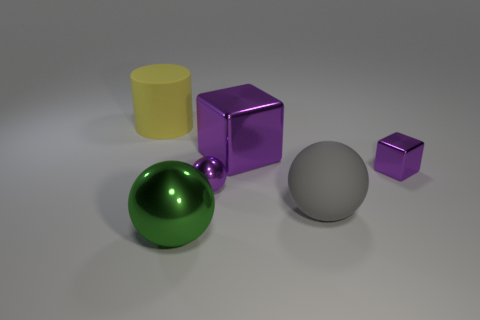Can you describe the colors and shapes visible in this image? Certainly! The image displays a collection of geometric shapes in various colors. There's a large yellow cylinder, a big shiny purple cube, a smaller cube in the same color, a green sphere with a reflective surface, and a neutral gray sphere. 